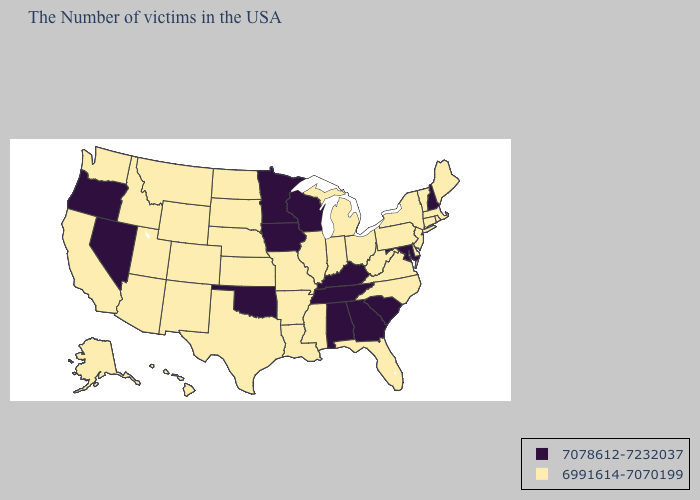What is the highest value in the South ?
Short answer required. 7078612-7232037. Which states hav the highest value in the MidWest?
Give a very brief answer. Wisconsin, Minnesota, Iowa. Does the first symbol in the legend represent the smallest category?
Short answer required. No. Name the states that have a value in the range 7078612-7232037?
Keep it brief. New Hampshire, Maryland, South Carolina, Georgia, Kentucky, Alabama, Tennessee, Wisconsin, Minnesota, Iowa, Oklahoma, Nevada, Oregon. What is the value of New Jersey?
Write a very short answer. 6991614-7070199. Name the states that have a value in the range 7078612-7232037?
Answer briefly. New Hampshire, Maryland, South Carolina, Georgia, Kentucky, Alabama, Tennessee, Wisconsin, Minnesota, Iowa, Oklahoma, Nevada, Oregon. What is the value of Georgia?
Write a very short answer. 7078612-7232037. Which states have the lowest value in the USA?
Keep it brief. Maine, Massachusetts, Rhode Island, Vermont, Connecticut, New York, New Jersey, Delaware, Pennsylvania, Virginia, North Carolina, West Virginia, Ohio, Florida, Michigan, Indiana, Illinois, Mississippi, Louisiana, Missouri, Arkansas, Kansas, Nebraska, Texas, South Dakota, North Dakota, Wyoming, Colorado, New Mexico, Utah, Montana, Arizona, Idaho, California, Washington, Alaska, Hawaii. Among the states that border Florida , which have the lowest value?
Be succinct. Georgia, Alabama. What is the value of Arizona?
Give a very brief answer. 6991614-7070199. Does Vermont have the lowest value in the USA?
Write a very short answer. Yes. What is the value of Georgia?
Quick response, please. 7078612-7232037. Name the states that have a value in the range 6991614-7070199?
Give a very brief answer. Maine, Massachusetts, Rhode Island, Vermont, Connecticut, New York, New Jersey, Delaware, Pennsylvania, Virginia, North Carolina, West Virginia, Ohio, Florida, Michigan, Indiana, Illinois, Mississippi, Louisiana, Missouri, Arkansas, Kansas, Nebraska, Texas, South Dakota, North Dakota, Wyoming, Colorado, New Mexico, Utah, Montana, Arizona, Idaho, California, Washington, Alaska, Hawaii. How many symbols are there in the legend?
Be succinct. 2. 